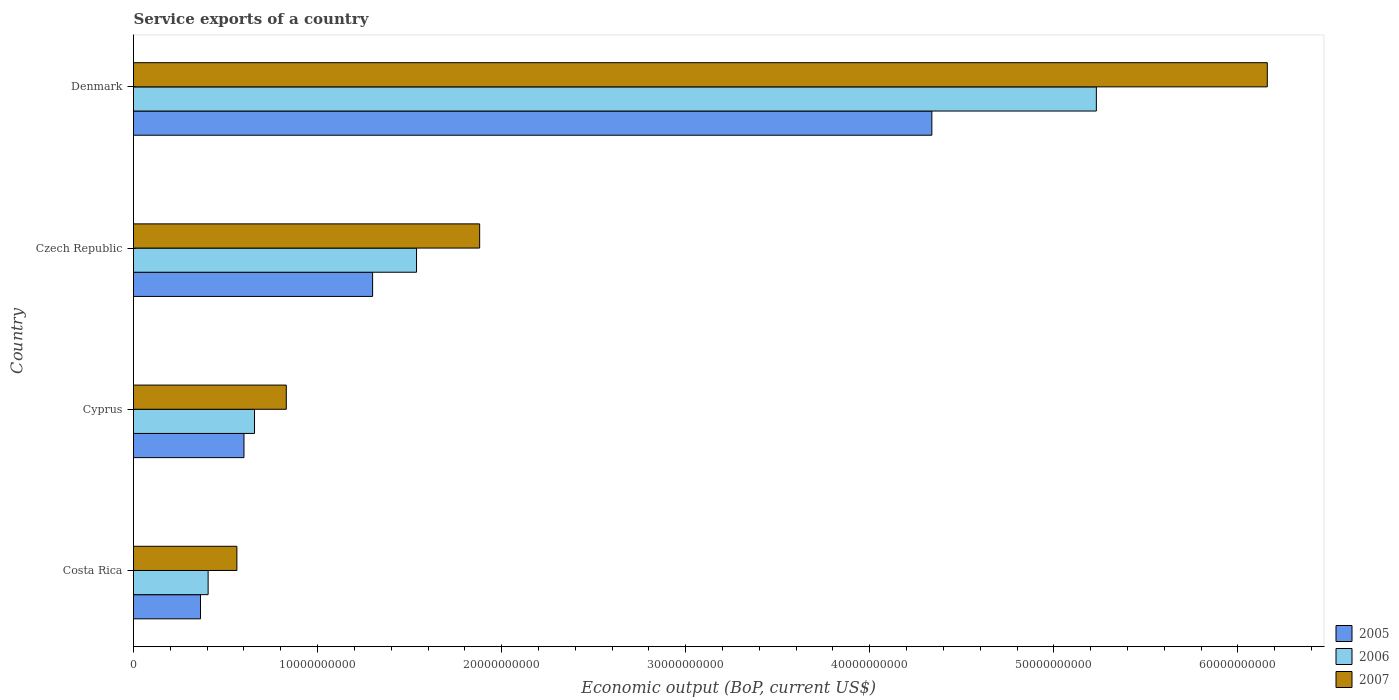How many groups of bars are there?
Offer a very short reply. 4. How many bars are there on the 1st tick from the bottom?
Your answer should be very brief. 3. What is the label of the 4th group of bars from the top?
Offer a terse response. Costa Rica. In how many cases, is the number of bars for a given country not equal to the number of legend labels?
Offer a terse response. 0. What is the service exports in 2005 in Czech Republic?
Make the answer very short. 1.30e+1. Across all countries, what is the maximum service exports in 2005?
Provide a short and direct response. 4.34e+1. Across all countries, what is the minimum service exports in 2005?
Provide a short and direct response. 3.64e+09. In which country was the service exports in 2005 maximum?
Give a very brief answer. Denmark. In which country was the service exports in 2007 minimum?
Your answer should be very brief. Costa Rica. What is the total service exports in 2007 in the graph?
Provide a short and direct response. 9.43e+1. What is the difference between the service exports in 2005 in Costa Rica and that in Cyprus?
Provide a succinct answer. -2.36e+09. What is the difference between the service exports in 2006 in Denmark and the service exports in 2005 in Czech Republic?
Make the answer very short. 3.93e+1. What is the average service exports in 2006 per country?
Ensure brevity in your answer.  1.96e+1. What is the difference between the service exports in 2006 and service exports in 2007 in Cyprus?
Your answer should be compact. -1.73e+09. What is the ratio of the service exports in 2007 in Costa Rica to that in Denmark?
Your answer should be compact. 0.09. Is the service exports in 2006 in Costa Rica less than that in Czech Republic?
Your answer should be compact. Yes. What is the difference between the highest and the second highest service exports in 2006?
Keep it short and to the point. 3.69e+1. What is the difference between the highest and the lowest service exports in 2007?
Ensure brevity in your answer.  5.60e+1. Is the sum of the service exports in 2005 in Costa Rica and Czech Republic greater than the maximum service exports in 2006 across all countries?
Your response must be concise. No. What does the 2nd bar from the bottom in Costa Rica represents?
Your response must be concise. 2006. Is it the case that in every country, the sum of the service exports in 2007 and service exports in 2005 is greater than the service exports in 2006?
Provide a succinct answer. Yes. What is the difference between two consecutive major ticks on the X-axis?
Give a very brief answer. 1.00e+1. Are the values on the major ticks of X-axis written in scientific E-notation?
Provide a succinct answer. No. Does the graph contain any zero values?
Give a very brief answer. No. Where does the legend appear in the graph?
Give a very brief answer. Bottom right. How are the legend labels stacked?
Make the answer very short. Vertical. What is the title of the graph?
Provide a short and direct response. Service exports of a country. What is the label or title of the X-axis?
Your response must be concise. Economic output (BoP, current US$). What is the label or title of the Y-axis?
Ensure brevity in your answer.  Country. What is the Economic output (BoP, current US$) in 2005 in Costa Rica?
Ensure brevity in your answer.  3.64e+09. What is the Economic output (BoP, current US$) in 2006 in Costa Rica?
Your answer should be very brief. 4.05e+09. What is the Economic output (BoP, current US$) of 2007 in Costa Rica?
Offer a terse response. 5.62e+09. What is the Economic output (BoP, current US$) in 2005 in Cyprus?
Your response must be concise. 6.00e+09. What is the Economic output (BoP, current US$) in 2006 in Cyprus?
Your answer should be compact. 6.57e+09. What is the Economic output (BoP, current US$) of 2007 in Cyprus?
Provide a short and direct response. 8.30e+09. What is the Economic output (BoP, current US$) of 2005 in Czech Republic?
Your answer should be compact. 1.30e+1. What is the Economic output (BoP, current US$) in 2006 in Czech Republic?
Give a very brief answer. 1.54e+1. What is the Economic output (BoP, current US$) in 2007 in Czech Republic?
Your answer should be very brief. 1.88e+1. What is the Economic output (BoP, current US$) of 2005 in Denmark?
Make the answer very short. 4.34e+1. What is the Economic output (BoP, current US$) in 2006 in Denmark?
Provide a succinct answer. 5.23e+1. What is the Economic output (BoP, current US$) in 2007 in Denmark?
Offer a terse response. 6.16e+1. Across all countries, what is the maximum Economic output (BoP, current US$) in 2005?
Offer a terse response. 4.34e+1. Across all countries, what is the maximum Economic output (BoP, current US$) of 2006?
Keep it short and to the point. 5.23e+1. Across all countries, what is the maximum Economic output (BoP, current US$) in 2007?
Give a very brief answer. 6.16e+1. Across all countries, what is the minimum Economic output (BoP, current US$) in 2005?
Make the answer very short. 3.64e+09. Across all countries, what is the minimum Economic output (BoP, current US$) of 2006?
Make the answer very short. 4.05e+09. Across all countries, what is the minimum Economic output (BoP, current US$) of 2007?
Ensure brevity in your answer.  5.62e+09. What is the total Economic output (BoP, current US$) in 2005 in the graph?
Make the answer very short. 6.60e+1. What is the total Economic output (BoP, current US$) of 2006 in the graph?
Your answer should be compact. 7.83e+1. What is the total Economic output (BoP, current US$) of 2007 in the graph?
Provide a succinct answer. 9.43e+1. What is the difference between the Economic output (BoP, current US$) in 2005 in Costa Rica and that in Cyprus?
Offer a very short reply. -2.36e+09. What is the difference between the Economic output (BoP, current US$) in 2006 in Costa Rica and that in Cyprus?
Give a very brief answer. -2.52e+09. What is the difference between the Economic output (BoP, current US$) in 2007 in Costa Rica and that in Cyprus?
Ensure brevity in your answer.  -2.68e+09. What is the difference between the Economic output (BoP, current US$) of 2005 in Costa Rica and that in Czech Republic?
Give a very brief answer. -9.35e+09. What is the difference between the Economic output (BoP, current US$) of 2006 in Costa Rica and that in Czech Republic?
Provide a short and direct response. -1.13e+1. What is the difference between the Economic output (BoP, current US$) of 2007 in Costa Rica and that in Czech Republic?
Your answer should be very brief. -1.32e+1. What is the difference between the Economic output (BoP, current US$) of 2005 in Costa Rica and that in Denmark?
Provide a short and direct response. -3.97e+1. What is the difference between the Economic output (BoP, current US$) in 2006 in Costa Rica and that in Denmark?
Your response must be concise. -4.83e+1. What is the difference between the Economic output (BoP, current US$) in 2007 in Costa Rica and that in Denmark?
Provide a short and direct response. -5.60e+1. What is the difference between the Economic output (BoP, current US$) in 2005 in Cyprus and that in Czech Republic?
Your answer should be compact. -6.99e+09. What is the difference between the Economic output (BoP, current US$) of 2006 in Cyprus and that in Czech Republic?
Keep it short and to the point. -8.80e+09. What is the difference between the Economic output (BoP, current US$) in 2007 in Cyprus and that in Czech Republic?
Offer a very short reply. -1.05e+1. What is the difference between the Economic output (BoP, current US$) in 2005 in Cyprus and that in Denmark?
Keep it short and to the point. -3.74e+1. What is the difference between the Economic output (BoP, current US$) in 2006 in Cyprus and that in Denmark?
Provide a short and direct response. -4.57e+1. What is the difference between the Economic output (BoP, current US$) of 2007 in Cyprus and that in Denmark?
Offer a terse response. -5.33e+1. What is the difference between the Economic output (BoP, current US$) of 2005 in Czech Republic and that in Denmark?
Your response must be concise. -3.04e+1. What is the difference between the Economic output (BoP, current US$) in 2006 in Czech Republic and that in Denmark?
Your response must be concise. -3.69e+1. What is the difference between the Economic output (BoP, current US$) of 2007 in Czech Republic and that in Denmark?
Offer a terse response. -4.28e+1. What is the difference between the Economic output (BoP, current US$) in 2005 in Costa Rica and the Economic output (BoP, current US$) in 2006 in Cyprus?
Give a very brief answer. -2.93e+09. What is the difference between the Economic output (BoP, current US$) in 2005 in Costa Rica and the Economic output (BoP, current US$) in 2007 in Cyprus?
Provide a short and direct response. -4.66e+09. What is the difference between the Economic output (BoP, current US$) of 2006 in Costa Rica and the Economic output (BoP, current US$) of 2007 in Cyprus?
Give a very brief answer. -4.25e+09. What is the difference between the Economic output (BoP, current US$) in 2005 in Costa Rica and the Economic output (BoP, current US$) in 2006 in Czech Republic?
Provide a short and direct response. -1.17e+1. What is the difference between the Economic output (BoP, current US$) in 2005 in Costa Rica and the Economic output (BoP, current US$) in 2007 in Czech Republic?
Make the answer very short. -1.52e+1. What is the difference between the Economic output (BoP, current US$) in 2006 in Costa Rica and the Economic output (BoP, current US$) in 2007 in Czech Republic?
Your answer should be very brief. -1.48e+1. What is the difference between the Economic output (BoP, current US$) of 2005 in Costa Rica and the Economic output (BoP, current US$) of 2006 in Denmark?
Provide a succinct answer. -4.87e+1. What is the difference between the Economic output (BoP, current US$) in 2005 in Costa Rica and the Economic output (BoP, current US$) in 2007 in Denmark?
Your answer should be very brief. -5.80e+1. What is the difference between the Economic output (BoP, current US$) of 2006 in Costa Rica and the Economic output (BoP, current US$) of 2007 in Denmark?
Provide a succinct answer. -5.75e+1. What is the difference between the Economic output (BoP, current US$) in 2005 in Cyprus and the Economic output (BoP, current US$) in 2006 in Czech Republic?
Make the answer very short. -9.37e+09. What is the difference between the Economic output (BoP, current US$) of 2005 in Cyprus and the Economic output (BoP, current US$) of 2007 in Czech Republic?
Provide a succinct answer. -1.28e+1. What is the difference between the Economic output (BoP, current US$) of 2006 in Cyprus and the Economic output (BoP, current US$) of 2007 in Czech Republic?
Provide a succinct answer. -1.22e+1. What is the difference between the Economic output (BoP, current US$) in 2005 in Cyprus and the Economic output (BoP, current US$) in 2006 in Denmark?
Provide a short and direct response. -4.63e+1. What is the difference between the Economic output (BoP, current US$) in 2005 in Cyprus and the Economic output (BoP, current US$) in 2007 in Denmark?
Ensure brevity in your answer.  -5.56e+1. What is the difference between the Economic output (BoP, current US$) in 2006 in Cyprus and the Economic output (BoP, current US$) in 2007 in Denmark?
Ensure brevity in your answer.  -5.50e+1. What is the difference between the Economic output (BoP, current US$) of 2005 in Czech Republic and the Economic output (BoP, current US$) of 2006 in Denmark?
Provide a short and direct response. -3.93e+1. What is the difference between the Economic output (BoP, current US$) of 2005 in Czech Republic and the Economic output (BoP, current US$) of 2007 in Denmark?
Your answer should be compact. -4.86e+1. What is the difference between the Economic output (BoP, current US$) in 2006 in Czech Republic and the Economic output (BoP, current US$) in 2007 in Denmark?
Provide a short and direct response. -4.62e+1. What is the average Economic output (BoP, current US$) of 2005 per country?
Ensure brevity in your answer.  1.65e+1. What is the average Economic output (BoP, current US$) in 2006 per country?
Make the answer very short. 1.96e+1. What is the average Economic output (BoP, current US$) in 2007 per country?
Give a very brief answer. 2.36e+1. What is the difference between the Economic output (BoP, current US$) of 2005 and Economic output (BoP, current US$) of 2006 in Costa Rica?
Your response must be concise. -4.14e+08. What is the difference between the Economic output (BoP, current US$) in 2005 and Economic output (BoP, current US$) in 2007 in Costa Rica?
Your answer should be very brief. -1.98e+09. What is the difference between the Economic output (BoP, current US$) in 2006 and Economic output (BoP, current US$) in 2007 in Costa Rica?
Give a very brief answer. -1.56e+09. What is the difference between the Economic output (BoP, current US$) of 2005 and Economic output (BoP, current US$) of 2006 in Cyprus?
Your answer should be compact. -5.72e+08. What is the difference between the Economic output (BoP, current US$) in 2005 and Economic output (BoP, current US$) in 2007 in Cyprus?
Your answer should be compact. -2.30e+09. What is the difference between the Economic output (BoP, current US$) in 2006 and Economic output (BoP, current US$) in 2007 in Cyprus?
Make the answer very short. -1.73e+09. What is the difference between the Economic output (BoP, current US$) of 2005 and Economic output (BoP, current US$) of 2006 in Czech Republic?
Offer a very short reply. -2.39e+09. What is the difference between the Economic output (BoP, current US$) in 2005 and Economic output (BoP, current US$) in 2007 in Czech Republic?
Give a very brief answer. -5.82e+09. What is the difference between the Economic output (BoP, current US$) in 2006 and Economic output (BoP, current US$) in 2007 in Czech Republic?
Your answer should be very brief. -3.43e+09. What is the difference between the Economic output (BoP, current US$) of 2005 and Economic output (BoP, current US$) of 2006 in Denmark?
Your answer should be compact. -8.94e+09. What is the difference between the Economic output (BoP, current US$) in 2005 and Economic output (BoP, current US$) in 2007 in Denmark?
Provide a succinct answer. -1.82e+1. What is the difference between the Economic output (BoP, current US$) in 2006 and Economic output (BoP, current US$) in 2007 in Denmark?
Provide a succinct answer. -9.29e+09. What is the ratio of the Economic output (BoP, current US$) in 2005 in Costa Rica to that in Cyprus?
Provide a short and direct response. 0.61. What is the ratio of the Economic output (BoP, current US$) of 2006 in Costa Rica to that in Cyprus?
Provide a short and direct response. 0.62. What is the ratio of the Economic output (BoP, current US$) of 2007 in Costa Rica to that in Cyprus?
Your answer should be very brief. 0.68. What is the ratio of the Economic output (BoP, current US$) in 2005 in Costa Rica to that in Czech Republic?
Make the answer very short. 0.28. What is the ratio of the Economic output (BoP, current US$) of 2006 in Costa Rica to that in Czech Republic?
Provide a succinct answer. 0.26. What is the ratio of the Economic output (BoP, current US$) in 2007 in Costa Rica to that in Czech Republic?
Your response must be concise. 0.3. What is the ratio of the Economic output (BoP, current US$) in 2005 in Costa Rica to that in Denmark?
Offer a terse response. 0.08. What is the ratio of the Economic output (BoP, current US$) in 2006 in Costa Rica to that in Denmark?
Give a very brief answer. 0.08. What is the ratio of the Economic output (BoP, current US$) of 2007 in Costa Rica to that in Denmark?
Provide a succinct answer. 0.09. What is the ratio of the Economic output (BoP, current US$) of 2005 in Cyprus to that in Czech Republic?
Ensure brevity in your answer.  0.46. What is the ratio of the Economic output (BoP, current US$) in 2006 in Cyprus to that in Czech Republic?
Offer a terse response. 0.43. What is the ratio of the Economic output (BoP, current US$) in 2007 in Cyprus to that in Czech Republic?
Your response must be concise. 0.44. What is the ratio of the Economic output (BoP, current US$) in 2005 in Cyprus to that in Denmark?
Keep it short and to the point. 0.14. What is the ratio of the Economic output (BoP, current US$) of 2006 in Cyprus to that in Denmark?
Keep it short and to the point. 0.13. What is the ratio of the Economic output (BoP, current US$) in 2007 in Cyprus to that in Denmark?
Provide a short and direct response. 0.13. What is the ratio of the Economic output (BoP, current US$) in 2005 in Czech Republic to that in Denmark?
Offer a very short reply. 0.3. What is the ratio of the Economic output (BoP, current US$) of 2006 in Czech Republic to that in Denmark?
Offer a very short reply. 0.29. What is the ratio of the Economic output (BoP, current US$) of 2007 in Czech Republic to that in Denmark?
Make the answer very short. 0.31. What is the difference between the highest and the second highest Economic output (BoP, current US$) of 2005?
Provide a short and direct response. 3.04e+1. What is the difference between the highest and the second highest Economic output (BoP, current US$) of 2006?
Offer a terse response. 3.69e+1. What is the difference between the highest and the second highest Economic output (BoP, current US$) in 2007?
Give a very brief answer. 4.28e+1. What is the difference between the highest and the lowest Economic output (BoP, current US$) in 2005?
Keep it short and to the point. 3.97e+1. What is the difference between the highest and the lowest Economic output (BoP, current US$) in 2006?
Your answer should be very brief. 4.83e+1. What is the difference between the highest and the lowest Economic output (BoP, current US$) of 2007?
Make the answer very short. 5.60e+1. 